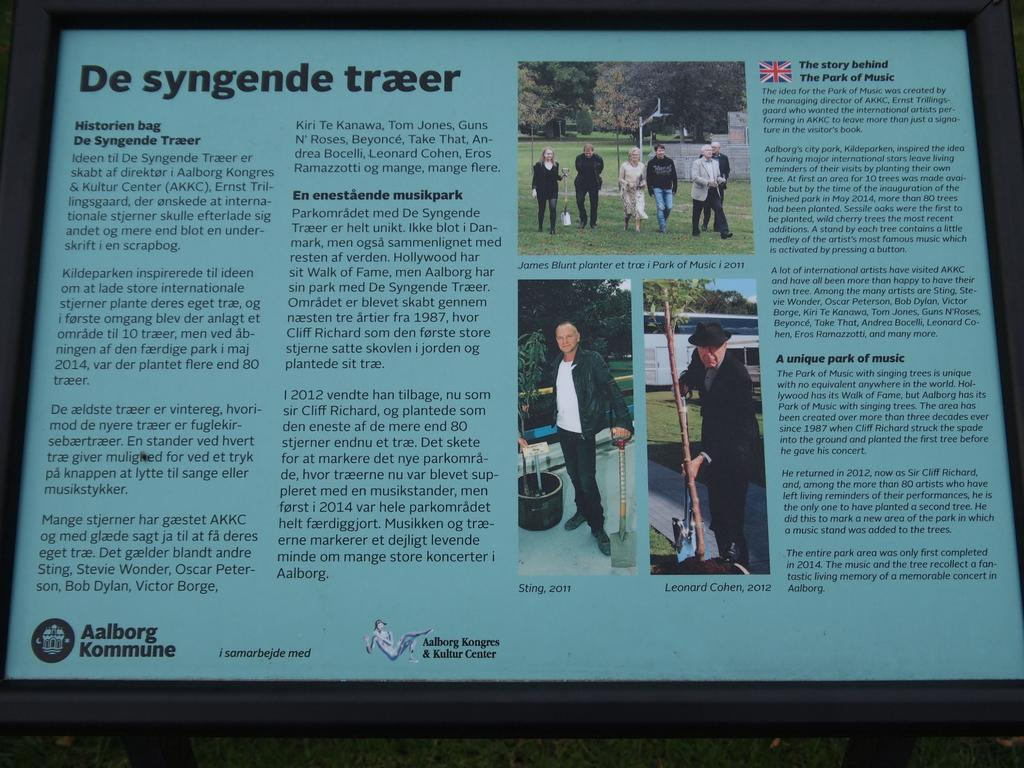<image>
Create a compact narrative representing the image presented. An article by Aalborg Kommune about the story behind the Park of Music. 